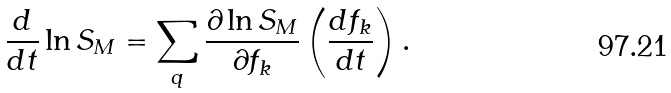<formula> <loc_0><loc_0><loc_500><loc_500>\frac { d } { d t } \ln S _ { M } = \sum _ { q } \frac { \partial \ln S _ { M } } { \partial f _ { k } } \left ( \frac { d f _ { k } } { d t } \right ) .</formula> 